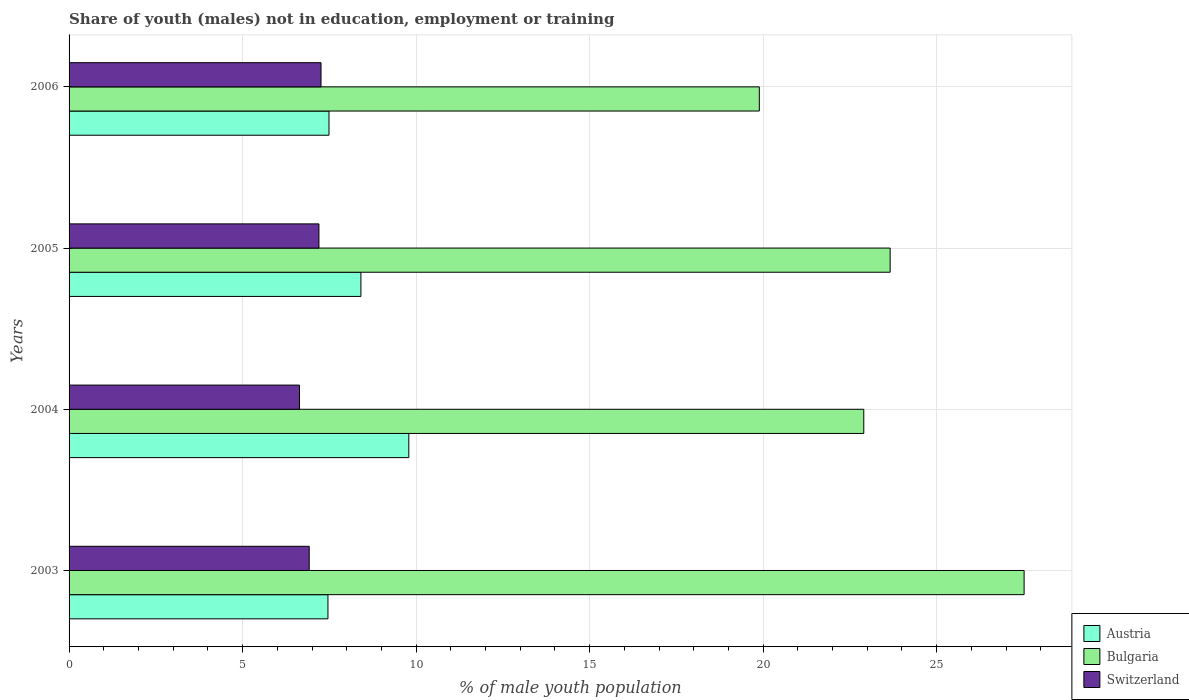How many different coloured bars are there?
Make the answer very short. 3. Are the number of bars on each tick of the Y-axis equal?
Make the answer very short. Yes. How many bars are there on the 4th tick from the top?
Your answer should be compact. 3. In how many cases, is the number of bars for a given year not equal to the number of legend labels?
Offer a very short reply. 0. What is the percentage of unemployed males population in in Bulgaria in 2003?
Make the answer very short. 27.52. Across all years, what is the maximum percentage of unemployed males population in in Switzerland?
Provide a succinct answer. 7.26. Across all years, what is the minimum percentage of unemployed males population in in Switzerland?
Ensure brevity in your answer.  6.64. In which year was the percentage of unemployed males population in in Bulgaria minimum?
Your answer should be compact. 2006. What is the total percentage of unemployed males population in in Bulgaria in the graph?
Your response must be concise. 93.97. What is the difference between the percentage of unemployed males population in in Austria in 2004 and that in 2006?
Ensure brevity in your answer.  2.3. What is the difference between the percentage of unemployed males population in in Bulgaria in 2004 and the percentage of unemployed males population in in Austria in 2003?
Give a very brief answer. 15.44. What is the average percentage of unemployed males population in in Bulgaria per year?
Keep it short and to the point. 23.49. In the year 2003, what is the difference between the percentage of unemployed males population in in Switzerland and percentage of unemployed males population in in Bulgaria?
Provide a succinct answer. -20.6. In how many years, is the percentage of unemployed males population in in Austria greater than 24 %?
Offer a very short reply. 0. What is the ratio of the percentage of unemployed males population in in Austria in 2004 to that in 2006?
Offer a terse response. 1.31. Is the percentage of unemployed males population in in Bulgaria in 2004 less than that in 2005?
Ensure brevity in your answer.  Yes. Is the difference between the percentage of unemployed males population in in Switzerland in 2003 and 2006 greater than the difference between the percentage of unemployed males population in in Bulgaria in 2003 and 2006?
Provide a short and direct response. No. What is the difference between the highest and the second highest percentage of unemployed males population in in Switzerland?
Provide a succinct answer. 0.06. What is the difference between the highest and the lowest percentage of unemployed males population in in Switzerland?
Ensure brevity in your answer.  0.62. What does the 1st bar from the top in 2004 represents?
Ensure brevity in your answer.  Switzerland. What does the 3rd bar from the bottom in 2004 represents?
Give a very brief answer. Switzerland. How many years are there in the graph?
Give a very brief answer. 4. What is the difference between two consecutive major ticks on the X-axis?
Your response must be concise. 5. Are the values on the major ticks of X-axis written in scientific E-notation?
Keep it short and to the point. No. Does the graph contain any zero values?
Ensure brevity in your answer.  No. How many legend labels are there?
Your answer should be compact. 3. What is the title of the graph?
Ensure brevity in your answer.  Share of youth (males) not in education, employment or training. What is the label or title of the X-axis?
Offer a very short reply. % of male youth population. What is the label or title of the Y-axis?
Provide a succinct answer. Years. What is the % of male youth population of Austria in 2003?
Provide a succinct answer. 7.46. What is the % of male youth population of Bulgaria in 2003?
Keep it short and to the point. 27.52. What is the % of male youth population of Switzerland in 2003?
Ensure brevity in your answer.  6.92. What is the % of male youth population in Austria in 2004?
Your answer should be very brief. 9.79. What is the % of male youth population in Bulgaria in 2004?
Ensure brevity in your answer.  22.9. What is the % of male youth population of Switzerland in 2004?
Your answer should be very brief. 6.64. What is the % of male youth population in Austria in 2005?
Make the answer very short. 8.41. What is the % of male youth population in Bulgaria in 2005?
Keep it short and to the point. 23.66. What is the % of male youth population of Switzerland in 2005?
Keep it short and to the point. 7.2. What is the % of male youth population of Austria in 2006?
Offer a very short reply. 7.49. What is the % of male youth population in Bulgaria in 2006?
Keep it short and to the point. 19.89. What is the % of male youth population of Switzerland in 2006?
Provide a short and direct response. 7.26. Across all years, what is the maximum % of male youth population in Austria?
Make the answer very short. 9.79. Across all years, what is the maximum % of male youth population of Bulgaria?
Offer a very short reply. 27.52. Across all years, what is the maximum % of male youth population in Switzerland?
Your answer should be very brief. 7.26. Across all years, what is the minimum % of male youth population of Austria?
Make the answer very short. 7.46. Across all years, what is the minimum % of male youth population of Bulgaria?
Keep it short and to the point. 19.89. Across all years, what is the minimum % of male youth population of Switzerland?
Keep it short and to the point. 6.64. What is the total % of male youth population in Austria in the graph?
Offer a very short reply. 33.15. What is the total % of male youth population of Bulgaria in the graph?
Offer a very short reply. 93.97. What is the total % of male youth population in Switzerland in the graph?
Ensure brevity in your answer.  28.02. What is the difference between the % of male youth population of Austria in 2003 and that in 2004?
Ensure brevity in your answer.  -2.33. What is the difference between the % of male youth population of Bulgaria in 2003 and that in 2004?
Your answer should be compact. 4.62. What is the difference between the % of male youth population in Switzerland in 2003 and that in 2004?
Provide a succinct answer. 0.28. What is the difference between the % of male youth population of Austria in 2003 and that in 2005?
Make the answer very short. -0.95. What is the difference between the % of male youth population in Bulgaria in 2003 and that in 2005?
Your response must be concise. 3.86. What is the difference between the % of male youth population in Switzerland in 2003 and that in 2005?
Provide a succinct answer. -0.28. What is the difference between the % of male youth population of Austria in 2003 and that in 2006?
Your response must be concise. -0.03. What is the difference between the % of male youth population of Bulgaria in 2003 and that in 2006?
Your response must be concise. 7.63. What is the difference between the % of male youth population of Switzerland in 2003 and that in 2006?
Offer a very short reply. -0.34. What is the difference between the % of male youth population of Austria in 2004 and that in 2005?
Make the answer very short. 1.38. What is the difference between the % of male youth population of Bulgaria in 2004 and that in 2005?
Your response must be concise. -0.76. What is the difference between the % of male youth population in Switzerland in 2004 and that in 2005?
Make the answer very short. -0.56. What is the difference between the % of male youth population of Austria in 2004 and that in 2006?
Offer a very short reply. 2.3. What is the difference between the % of male youth population of Bulgaria in 2004 and that in 2006?
Your answer should be very brief. 3.01. What is the difference between the % of male youth population of Switzerland in 2004 and that in 2006?
Provide a short and direct response. -0.62. What is the difference between the % of male youth population of Bulgaria in 2005 and that in 2006?
Make the answer very short. 3.77. What is the difference between the % of male youth population in Switzerland in 2005 and that in 2006?
Ensure brevity in your answer.  -0.06. What is the difference between the % of male youth population in Austria in 2003 and the % of male youth population in Bulgaria in 2004?
Your answer should be very brief. -15.44. What is the difference between the % of male youth population of Austria in 2003 and the % of male youth population of Switzerland in 2004?
Your answer should be compact. 0.82. What is the difference between the % of male youth population of Bulgaria in 2003 and the % of male youth population of Switzerland in 2004?
Make the answer very short. 20.88. What is the difference between the % of male youth population in Austria in 2003 and the % of male youth population in Bulgaria in 2005?
Provide a succinct answer. -16.2. What is the difference between the % of male youth population in Austria in 2003 and the % of male youth population in Switzerland in 2005?
Give a very brief answer. 0.26. What is the difference between the % of male youth population in Bulgaria in 2003 and the % of male youth population in Switzerland in 2005?
Make the answer very short. 20.32. What is the difference between the % of male youth population in Austria in 2003 and the % of male youth population in Bulgaria in 2006?
Give a very brief answer. -12.43. What is the difference between the % of male youth population in Austria in 2003 and the % of male youth population in Switzerland in 2006?
Make the answer very short. 0.2. What is the difference between the % of male youth population in Bulgaria in 2003 and the % of male youth population in Switzerland in 2006?
Ensure brevity in your answer.  20.26. What is the difference between the % of male youth population in Austria in 2004 and the % of male youth population in Bulgaria in 2005?
Offer a terse response. -13.87. What is the difference between the % of male youth population in Austria in 2004 and the % of male youth population in Switzerland in 2005?
Provide a short and direct response. 2.59. What is the difference between the % of male youth population of Bulgaria in 2004 and the % of male youth population of Switzerland in 2005?
Your answer should be very brief. 15.7. What is the difference between the % of male youth population of Austria in 2004 and the % of male youth population of Switzerland in 2006?
Make the answer very short. 2.53. What is the difference between the % of male youth population of Bulgaria in 2004 and the % of male youth population of Switzerland in 2006?
Provide a succinct answer. 15.64. What is the difference between the % of male youth population of Austria in 2005 and the % of male youth population of Bulgaria in 2006?
Your answer should be very brief. -11.48. What is the difference between the % of male youth population in Austria in 2005 and the % of male youth population in Switzerland in 2006?
Ensure brevity in your answer.  1.15. What is the difference between the % of male youth population in Bulgaria in 2005 and the % of male youth population in Switzerland in 2006?
Make the answer very short. 16.4. What is the average % of male youth population in Austria per year?
Offer a very short reply. 8.29. What is the average % of male youth population of Bulgaria per year?
Make the answer very short. 23.49. What is the average % of male youth population of Switzerland per year?
Keep it short and to the point. 7. In the year 2003, what is the difference between the % of male youth population of Austria and % of male youth population of Bulgaria?
Make the answer very short. -20.06. In the year 2003, what is the difference between the % of male youth population of Austria and % of male youth population of Switzerland?
Ensure brevity in your answer.  0.54. In the year 2003, what is the difference between the % of male youth population in Bulgaria and % of male youth population in Switzerland?
Your answer should be very brief. 20.6. In the year 2004, what is the difference between the % of male youth population in Austria and % of male youth population in Bulgaria?
Your answer should be compact. -13.11. In the year 2004, what is the difference between the % of male youth population of Austria and % of male youth population of Switzerland?
Offer a very short reply. 3.15. In the year 2004, what is the difference between the % of male youth population in Bulgaria and % of male youth population in Switzerland?
Your answer should be very brief. 16.26. In the year 2005, what is the difference between the % of male youth population in Austria and % of male youth population in Bulgaria?
Ensure brevity in your answer.  -15.25. In the year 2005, what is the difference between the % of male youth population of Austria and % of male youth population of Switzerland?
Your answer should be compact. 1.21. In the year 2005, what is the difference between the % of male youth population in Bulgaria and % of male youth population in Switzerland?
Your answer should be very brief. 16.46. In the year 2006, what is the difference between the % of male youth population of Austria and % of male youth population of Switzerland?
Your answer should be compact. 0.23. In the year 2006, what is the difference between the % of male youth population of Bulgaria and % of male youth population of Switzerland?
Provide a succinct answer. 12.63. What is the ratio of the % of male youth population in Austria in 2003 to that in 2004?
Your answer should be very brief. 0.76. What is the ratio of the % of male youth population of Bulgaria in 2003 to that in 2004?
Make the answer very short. 1.2. What is the ratio of the % of male youth population of Switzerland in 2003 to that in 2004?
Ensure brevity in your answer.  1.04. What is the ratio of the % of male youth population in Austria in 2003 to that in 2005?
Keep it short and to the point. 0.89. What is the ratio of the % of male youth population in Bulgaria in 2003 to that in 2005?
Keep it short and to the point. 1.16. What is the ratio of the % of male youth population of Switzerland in 2003 to that in 2005?
Your answer should be very brief. 0.96. What is the ratio of the % of male youth population in Austria in 2003 to that in 2006?
Your response must be concise. 1. What is the ratio of the % of male youth population in Bulgaria in 2003 to that in 2006?
Keep it short and to the point. 1.38. What is the ratio of the % of male youth population of Switzerland in 2003 to that in 2006?
Ensure brevity in your answer.  0.95. What is the ratio of the % of male youth population in Austria in 2004 to that in 2005?
Offer a terse response. 1.16. What is the ratio of the % of male youth population in Bulgaria in 2004 to that in 2005?
Ensure brevity in your answer.  0.97. What is the ratio of the % of male youth population of Switzerland in 2004 to that in 2005?
Give a very brief answer. 0.92. What is the ratio of the % of male youth population of Austria in 2004 to that in 2006?
Your answer should be compact. 1.31. What is the ratio of the % of male youth population in Bulgaria in 2004 to that in 2006?
Your response must be concise. 1.15. What is the ratio of the % of male youth population in Switzerland in 2004 to that in 2006?
Give a very brief answer. 0.91. What is the ratio of the % of male youth population of Austria in 2005 to that in 2006?
Provide a short and direct response. 1.12. What is the ratio of the % of male youth population in Bulgaria in 2005 to that in 2006?
Offer a terse response. 1.19. What is the ratio of the % of male youth population of Switzerland in 2005 to that in 2006?
Make the answer very short. 0.99. What is the difference between the highest and the second highest % of male youth population of Austria?
Give a very brief answer. 1.38. What is the difference between the highest and the second highest % of male youth population of Bulgaria?
Provide a short and direct response. 3.86. What is the difference between the highest and the lowest % of male youth population of Austria?
Give a very brief answer. 2.33. What is the difference between the highest and the lowest % of male youth population in Bulgaria?
Provide a succinct answer. 7.63. What is the difference between the highest and the lowest % of male youth population in Switzerland?
Offer a terse response. 0.62. 